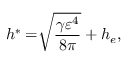<formula> <loc_0><loc_0><loc_500><loc_500>h ^ { \ast } = \sqrt { [ } ] { \frac { \gamma \varepsilon ^ { 4 } } { 8 \pi } } + h _ { e } ,</formula> 